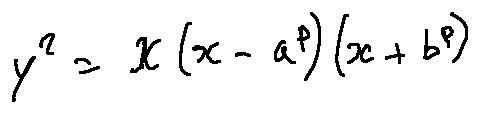Convert formula to latex. <formula><loc_0><loc_0><loc_500><loc_500>y ^ { 2 } = x ( x - a ^ { p } ) ( x + b ^ { p } )</formula> 